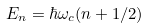Convert formula to latex. <formula><loc_0><loc_0><loc_500><loc_500>E _ { n } = \hbar { \omega } _ { c } ( n + 1 / 2 )</formula> 